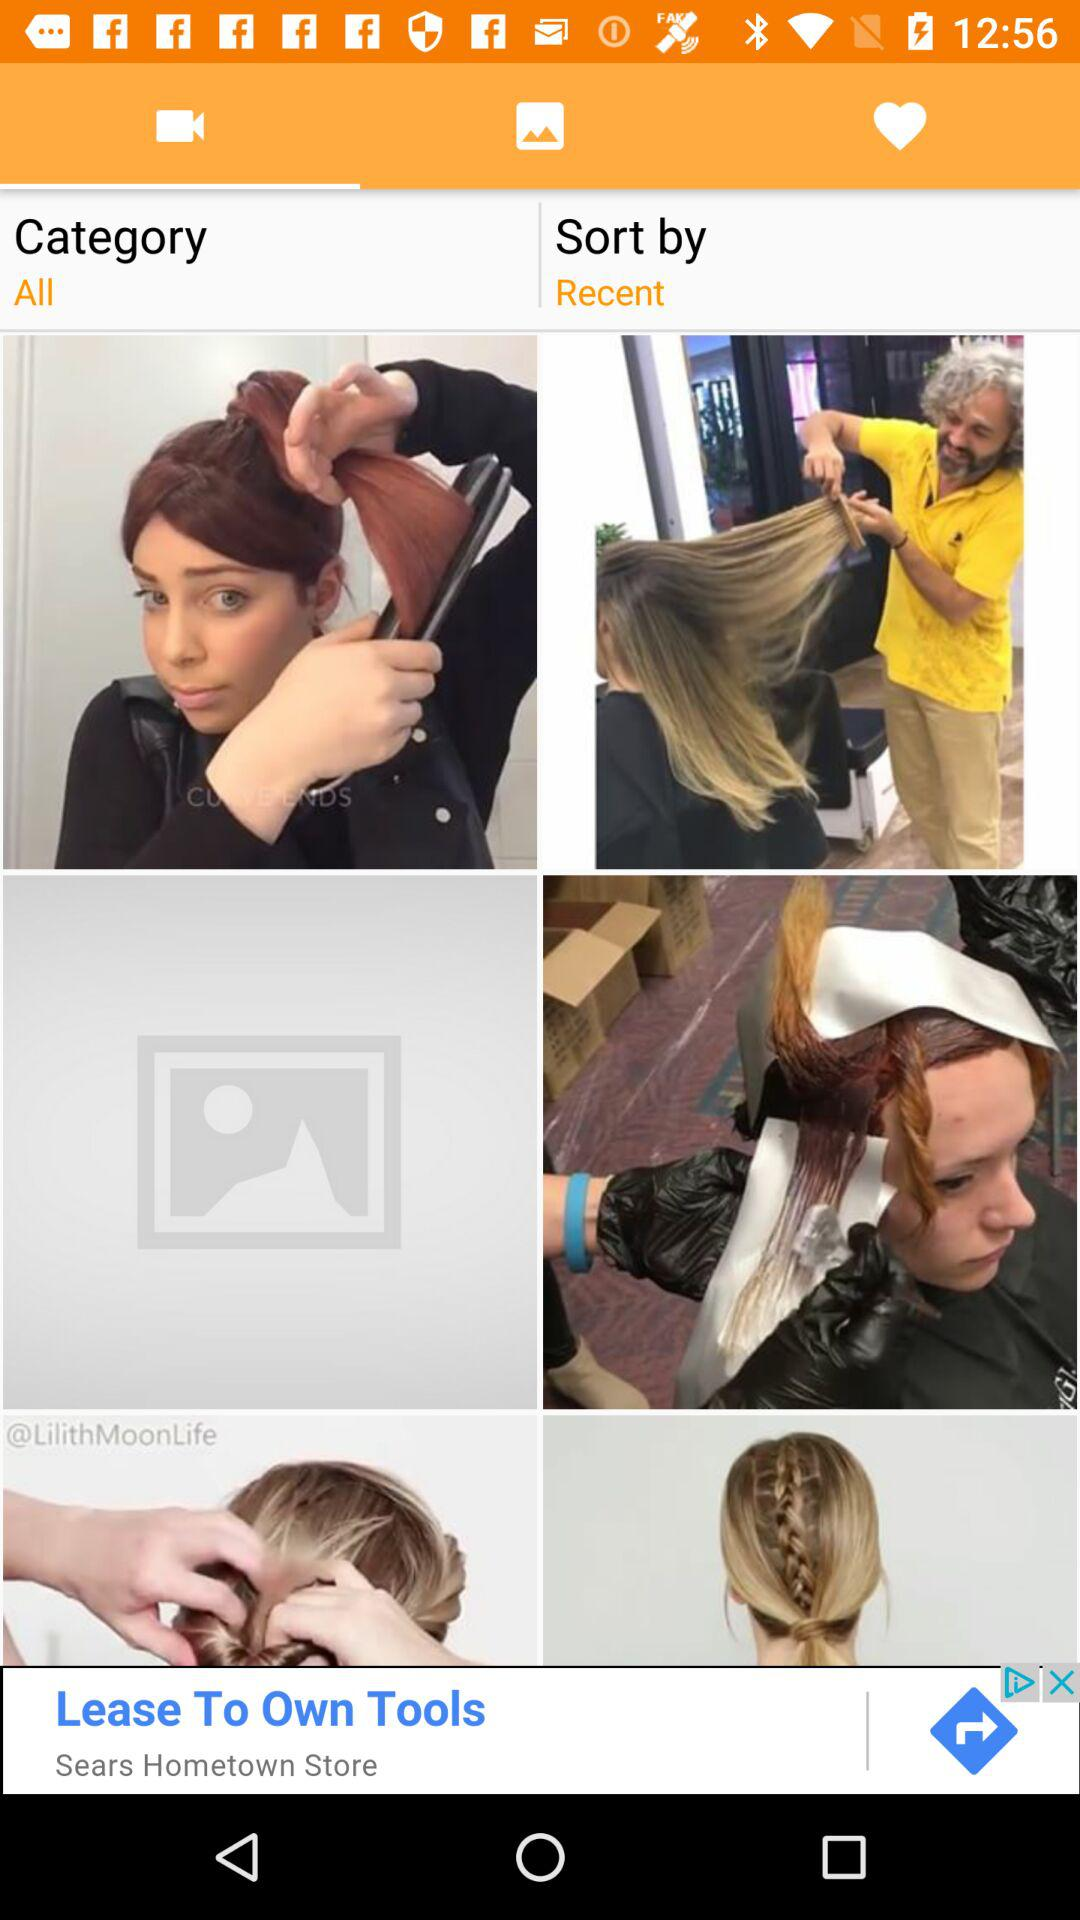Which is the selected tab? The selected tab is "Videos". 